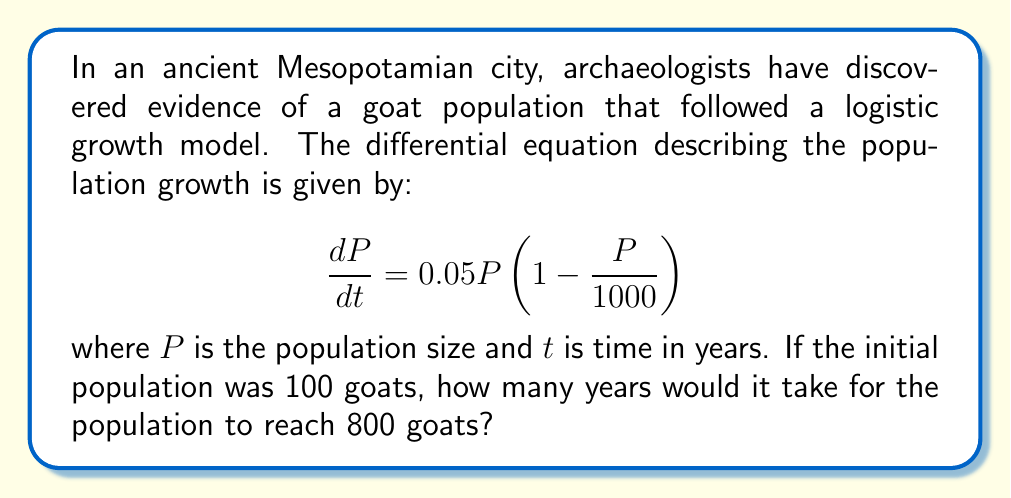Help me with this question. To solve this problem, we need to use the solution to the logistic differential equation:

1) The general solution to the logistic equation is:

   $$P(t) = \frac{K}{1 + (\frac{K}{P_0} - 1)e^{-rt}}$$

   where $K$ is the carrying capacity, $P_0$ is the initial population, and $r$ is the growth rate.

2) From our equation, we can identify:
   $K = 1000$ (carrying capacity)
   $r = 0.05$ (growth rate)
   $P_0 = 100$ (initial population)

3) Substituting these values:

   $$P(t) = \frac{1000}{1 + (10 - 1)e^{-0.05t}}$$

4) We want to find $t$ when $P(t) = 800$. Let's substitute this:

   $$800 = \frac{1000}{1 + 9e^{-0.05t}}$$

5) Solving for $t$:
   
   $1 + 9e^{-0.05t} = \frac{1000}{800} = 1.25$
   
   $9e^{-0.05t} = 0.25$
   
   $e^{-0.05t} = \frac{1}{36}$
   
   $-0.05t = \ln(\frac{1}{36})$
   
   $t = -\frac{1}{0.05}\ln(\frac{1}{36}) \approx 71.89$ years

6) Rounding up to the nearest year, it would take 72 years for the population to reach 800 goats.
Answer: 72 years 